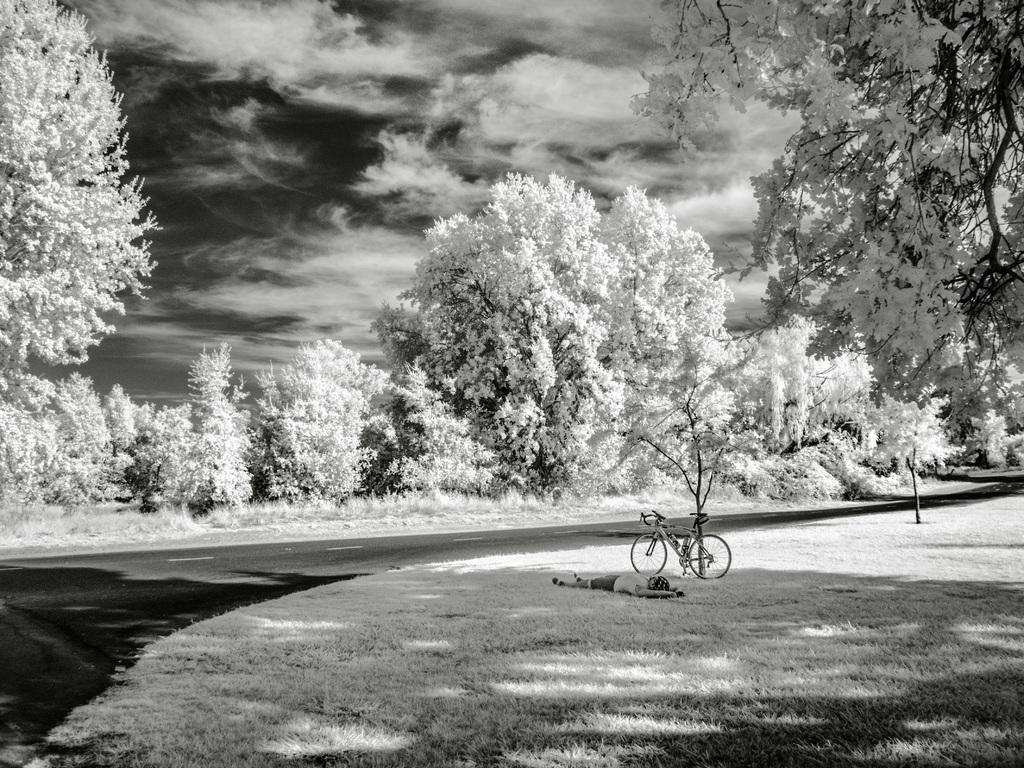Could you give a brief overview of what you see in this image? In this image there is the sky towards the top of the image, there are clouds in the sky, there are trees, there is the road, there is grass towards the bottom of the image, there is a bicycle, there is a man sleeping on the grass. 